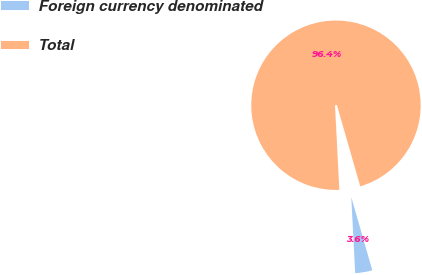Convert chart to OTSL. <chart><loc_0><loc_0><loc_500><loc_500><pie_chart><fcel>Foreign currency denominated<fcel>Total<nl><fcel>3.63%<fcel>96.37%<nl></chart> 